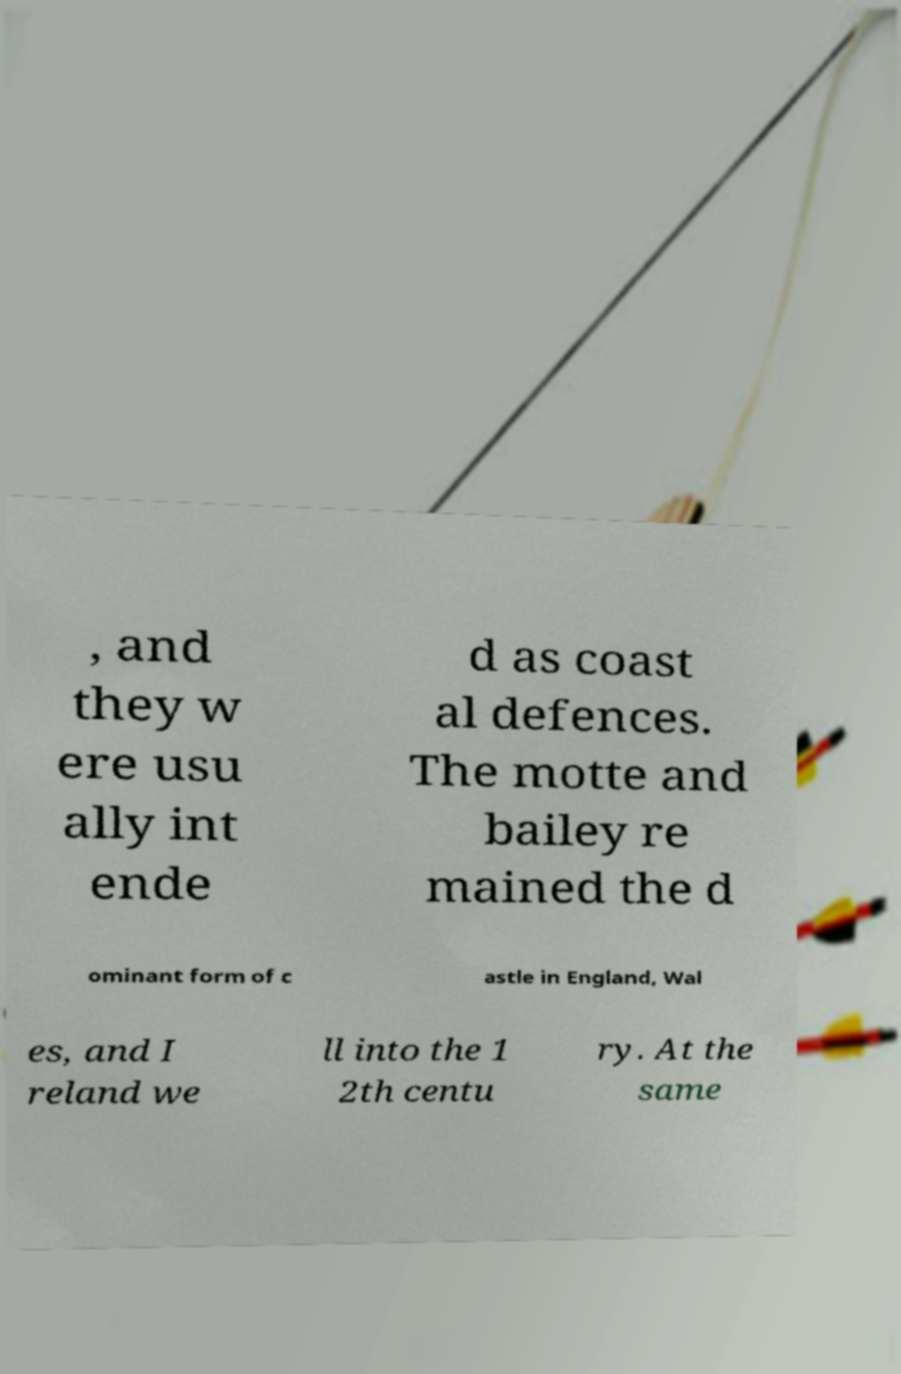Please identify and transcribe the text found in this image. , and they w ere usu ally int ende d as coast al defences. The motte and bailey re mained the d ominant form of c astle in England, Wal es, and I reland we ll into the 1 2th centu ry. At the same 